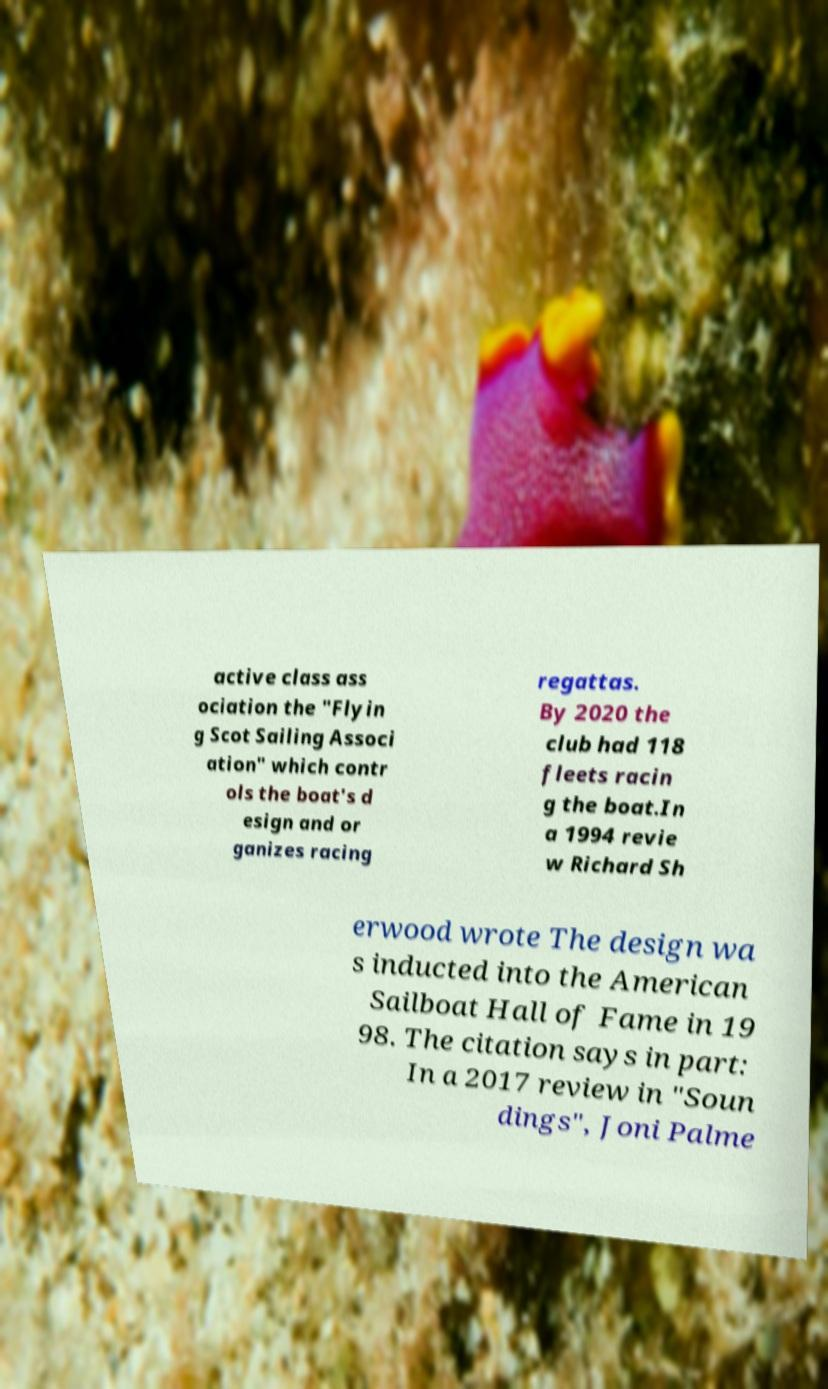Could you extract and type out the text from this image? active class ass ociation the "Flyin g Scot Sailing Associ ation" which contr ols the boat's d esign and or ganizes racing regattas. By 2020 the club had 118 fleets racin g the boat.In a 1994 revie w Richard Sh erwood wrote The design wa s inducted into the American Sailboat Hall of Fame in 19 98. The citation says in part: In a 2017 review in "Soun dings", Joni Palme 